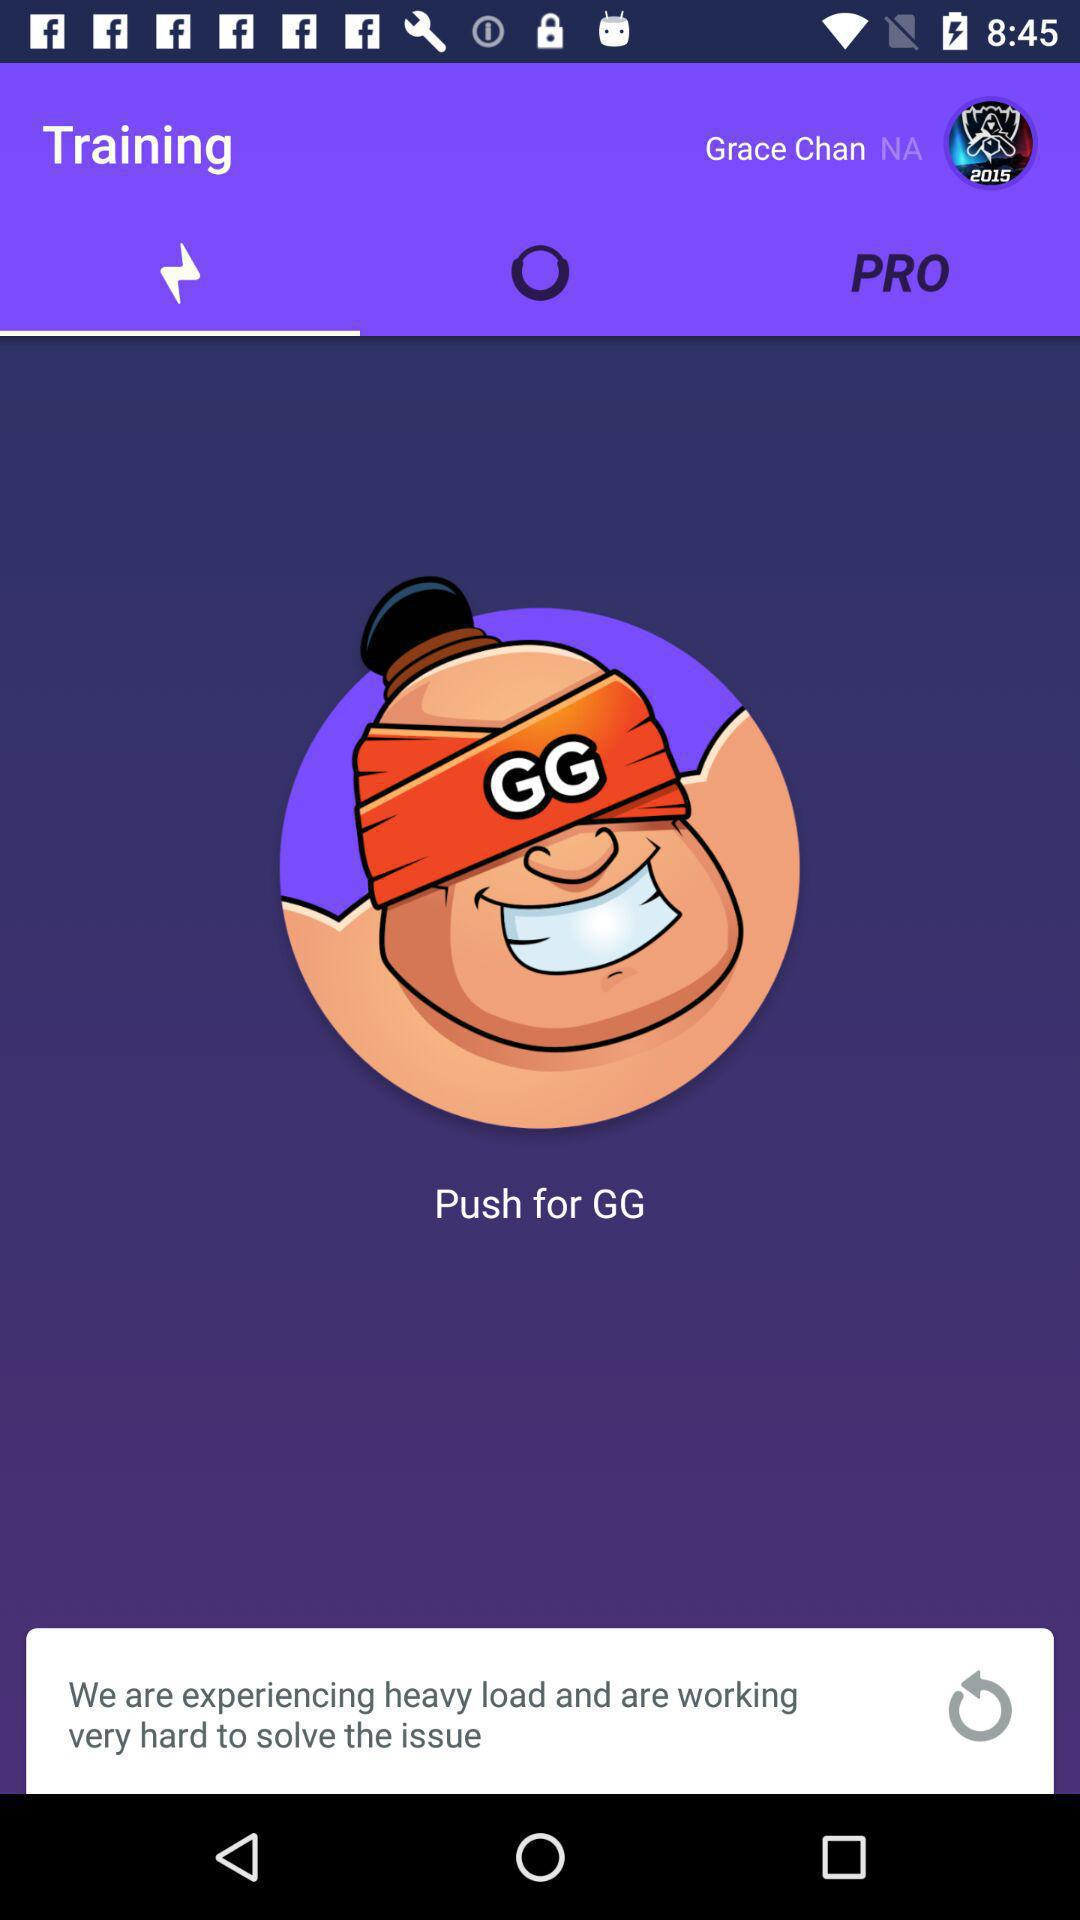What is the name of the user? The name of the user is Grace Chan. 